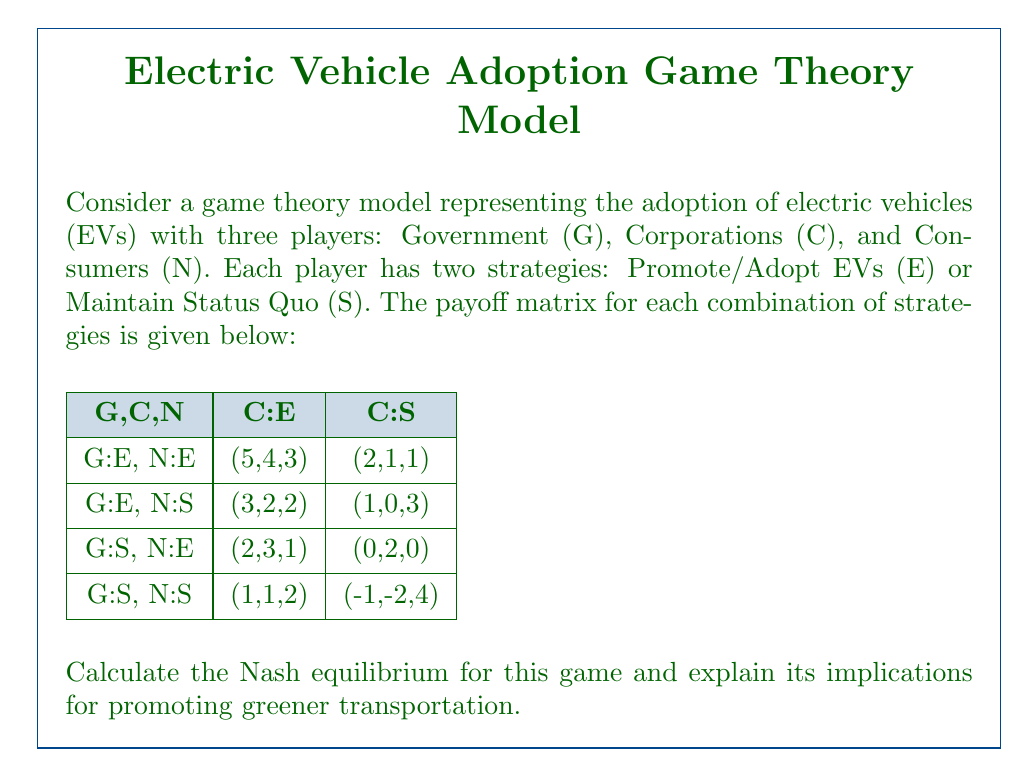Solve this math problem. To find the Nash equilibrium, we need to analyze each player's best response to the other players' strategies.

1. Government's perspective:
   - If C:E and N:E, G prefers E (5 > 2)
   - If C:E and N:S, G prefers E (3 > 2)
   - If C:S and N:E, G prefers E (2 > 0)
   - If C:S and N:S, G prefers E (1 > -1)

   Government's dominant strategy is E.

2. Corporations' perspective:
   - If G:E and N:E, C prefers E (4 > 1)
   - If G:E and N:S, C prefers E (2 > 0)
   - If G:S and N:E, C prefers E (3 > 2)
   - If G:S and N:S, C prefers E (1 > -2)

   Corporations' dominant strategy is E.

3. Consumers' perspective:
   - If G:E and C:E, N prefers E (3 > 2)
   - If G:E and C:S, N prefers S (3 > 1)
   - If G:S and C:E, N prefers S (2 > 1)
   - If G:S and C:S, N prefers S (4 > 0)

   Consumers don't have a dominant strategy.

Given that G and C have dominant strategies (both E), we can simplify the game to focus on N's decision:

$$
\begin{array}{c|c}
\text{N} & \text{Payoff} \\
\hline
\text{E} & 3 \\
\text{S} & 2 \\
\end{array}
$$

Consumers will choose E as it gives a higher payoff (3 > 2).

Therefore, the Nash equilibrium is (G:E, C:E, N:E) with payoffs (5,4,3).

Implications:
1. Government promotion of EVs through policies and incentives is crucial.
2. Corporate investment in EV technology and infrastructure is beneficial.
3. Consumer adoption of EVs is encouraged when both government and corporations support the transition.
4. This equilibrium represents a positive outcome for promoting greener transportation, as all parties benefit from the adoption of electric vehicles.
Answer: The Nash equilibrium is (G:E, C:E, N:E) with payoffs (5,4,3), indicating that all players choose to promote or adopt electric vehicles. 